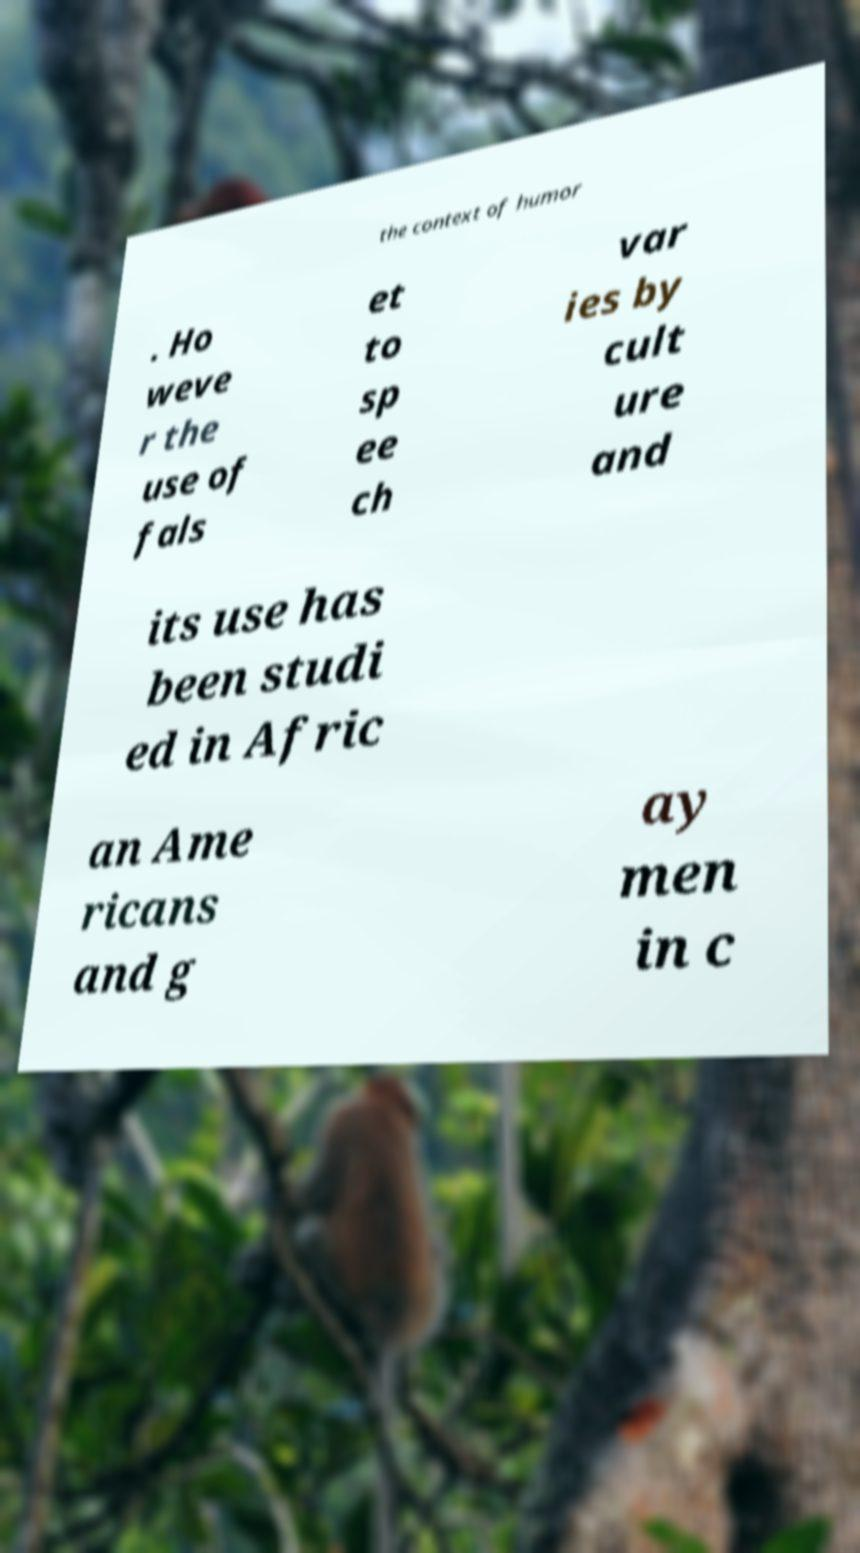Please identify and transcribe the text found in this image. the context of humor . Ho weve r the use of fals et to sp ee ch var ies by cult ure and its use has been studi ed in Afric an Ame ricans and g ay men in c 